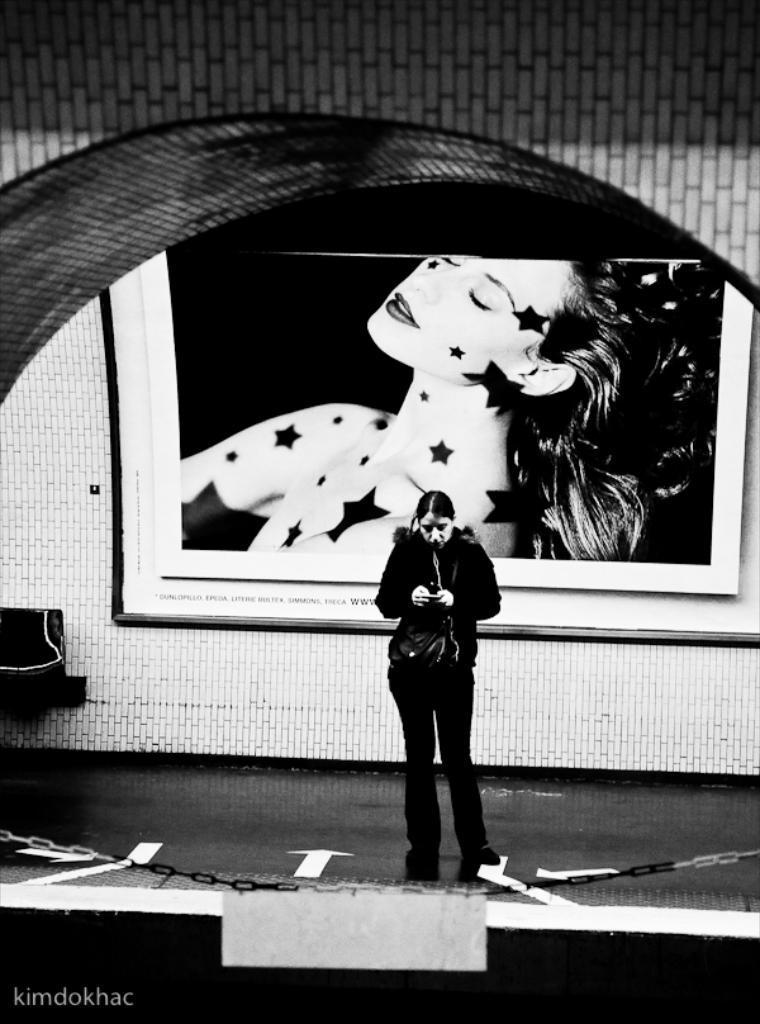Describe this image in one or two sentences. This is a black and white image. Here is the woman standing. This looks like a photo frame, which is attached to the wall. On the left side of the image, I think this is a chair. I can see an iron chain hanging. This looks like a platform. I can see the watermark on the image. 